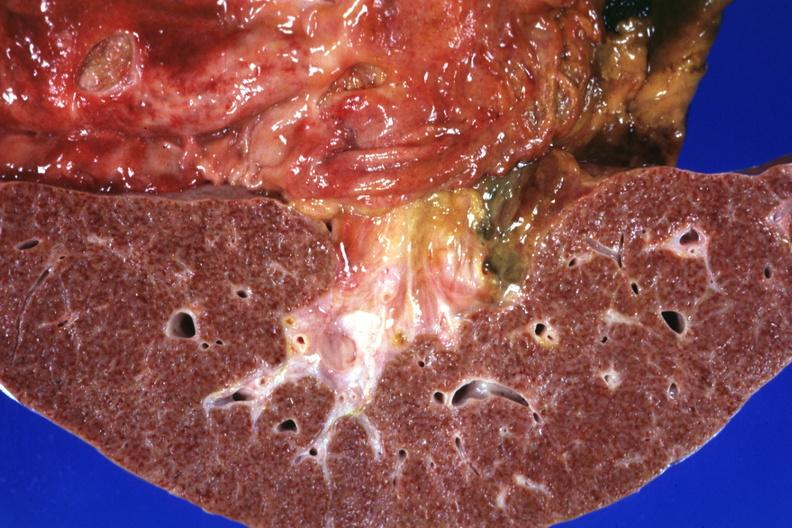how does this frontal section micronodular photo show gastric and ulcers?
Answer the question using a single word or phrase. Duodenal 